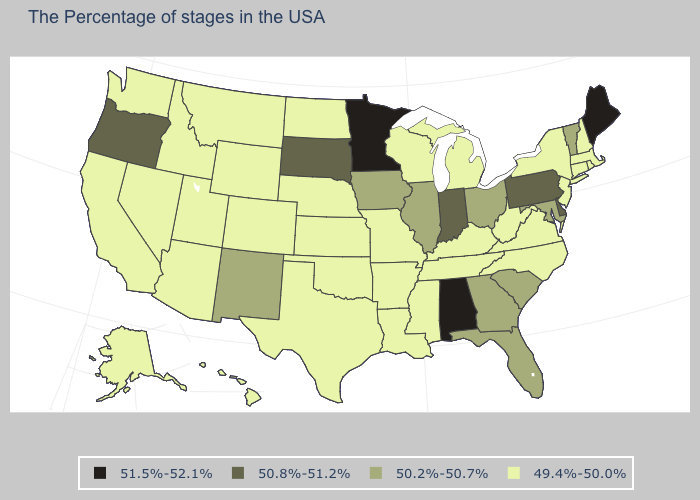What is the lowest value in the West?
Write a very short answer. 49.4%-50.0%. Which states have the lowest value in the USA?
Answer briefly. Massachusetts, Rhode Island, New Hampshire, Connecticut, New York, New Jersey, Virginia, North Carolina, West Virginia, Michigan, Kentucky, Tennessee, Wisconsin, Mississippi, Louisiana, Missouri, Arkansas, Kansas, Nebraska, Oklahoma, Texas, North Dakota, Wyoming, Colorado, Utah, Montana, Arizona, Idaho, Nevada, California, Washington, Alaska, Hawaii. What is the value of Connecticut?
Give a very brief answer. 49.4%-50.0%. Name the states that have a value in the range 50.2%-50.7%?
Write a very short answer. Vermont, Maryland, South Carolina, Ohio, Florida, Georgia, Illinois, Iowa, New Mexico. Does Alabama have the lowest value in the USA?
Short answer required. No. What is the value of Nebraska?
Keep it brief. 49.4%-50.0%. Does Indiana have the highest value in the MidWest?
Write a very short answer. No. Does Maine have a higher value than Minnesota?
Answer briefly. No. Name the states that have a value in the range 50.2%-50.7%?
Quick response, please. Vermont, Maryland, South Carolina, Ohio, Florida, Georgia, Illinois, Iowa, New Mexico. Among the states that border Washington , which have the highest value?
Write a very short answer. Oregon. Among the states that border Washington , which have the highest value?
Concise answer only. Oregon. Name the states that have a value in the range 49.4%-50.0%?
Short answer required. Massachusetts, Rhode Island, New Hampshire, Connecticut, New York, New Jersey, Virginia, North Carolina, West Virginia, Michigan, Kentucky, Tennessee, Wisconsin, Mississippi, Louisiana, Missouri, Arkansas, Kansas, Nebraska, Oklahoma, Texas, North Dakota, Wyoming, Colorado, Utah, Montana, Arizona, Idaho, Nevada, California, Washington, Alaska, Hawaii. Name the states that have a value in the range 51.5%-52.1%?
Short answer required. Maine, Alabama, Minnesota. What is the value of Florida?
Answer briefly. 50.2%-50.7%. 